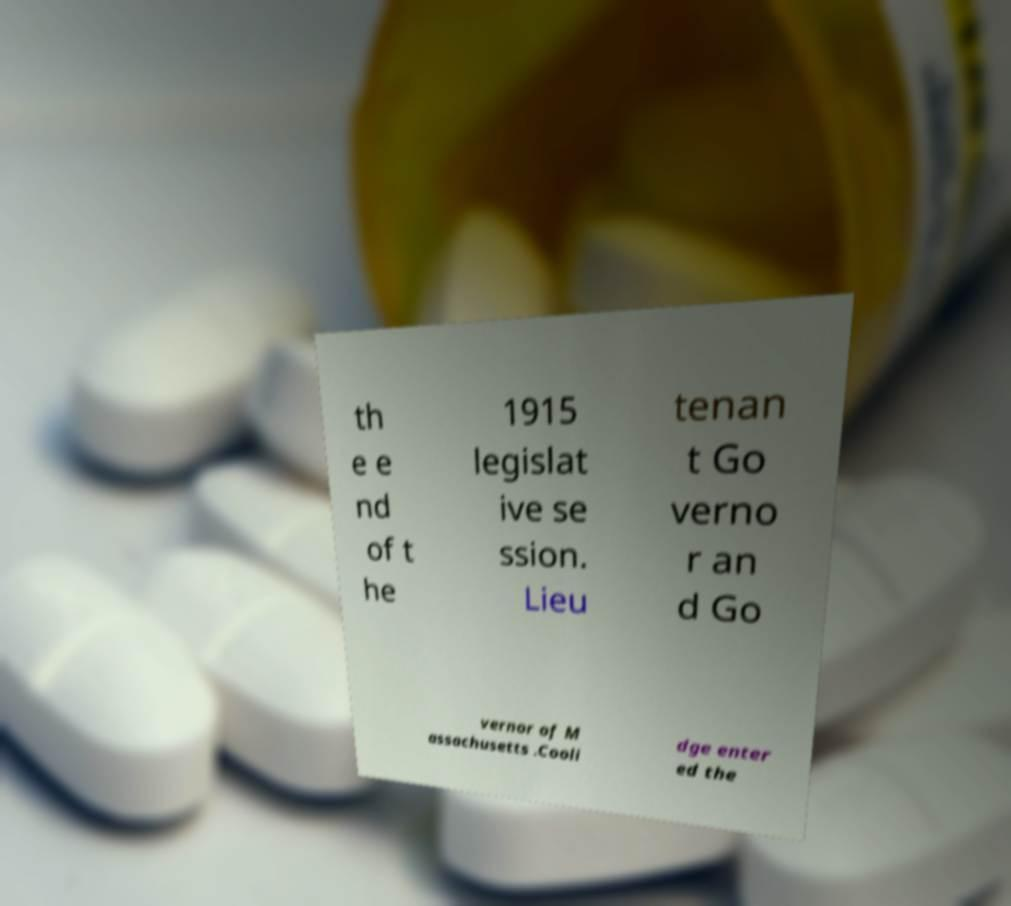For documentation purposes, I need the text within this image transcribed. Could you provide that? th e e nd of t he 1915 legislat ive se ssion. Lieu tenan t Go verno r an d Go vernor of M assachusetts .Cooli dge enter ed the 